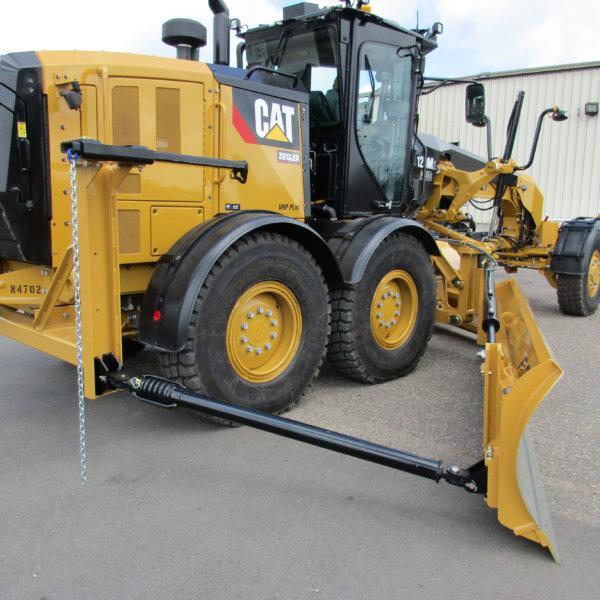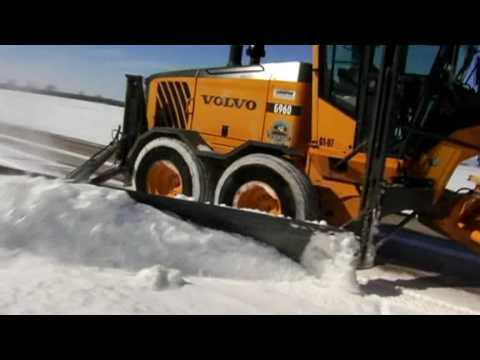The first image is the image on the left, the second image is the image on the right. Given the left and right images, does the statement "The left and right image contains the same number of yellow snow plows." hold true? Answer yes or no. Yes. 